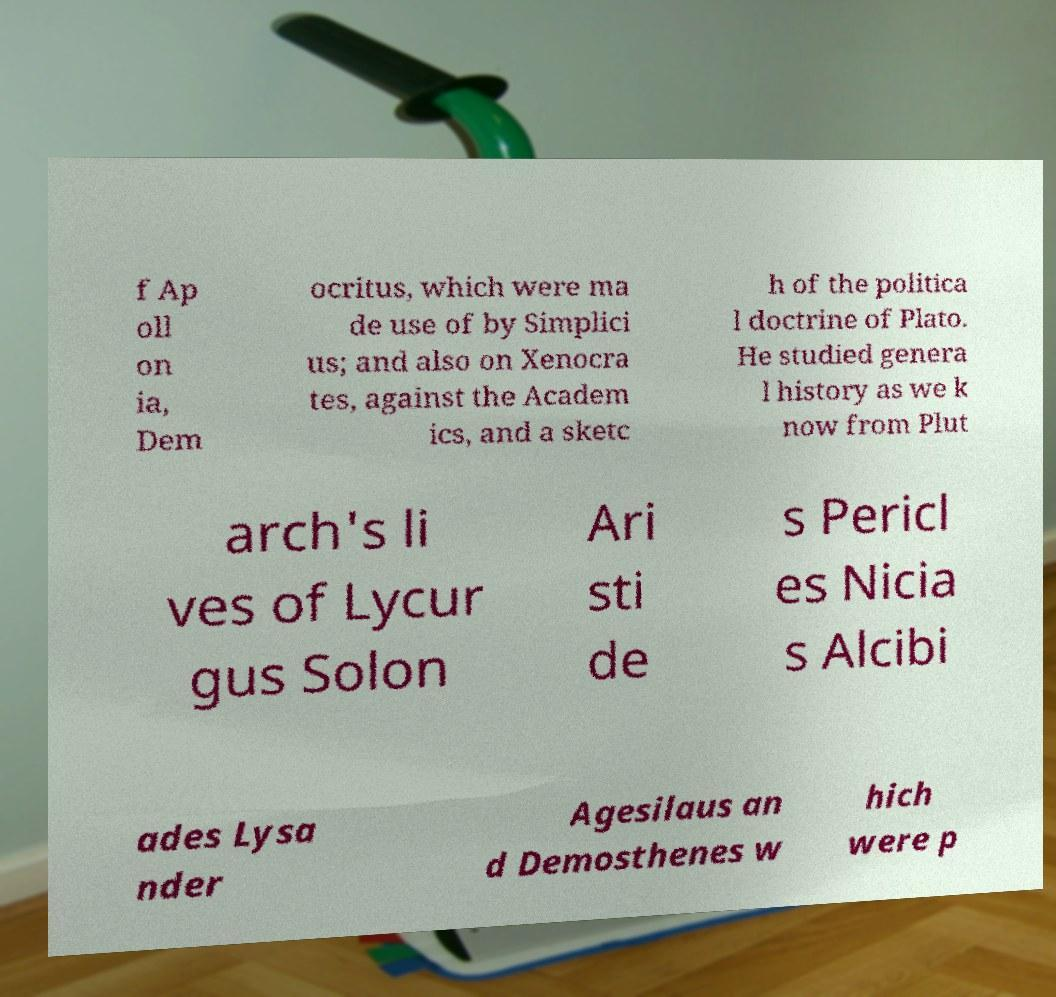Please read and relay the text visible in this image. What does it say? f Ap oll on ia, Dem ocritus, which were ma de use of by Simplici us; and also on Xenocra tes, against the Academ ics, and a sketc h of the politica l doctrine of Plato. He studied genera l history as we k now from Plut arch's li ves of Lycur gus Solon Ari sti de s Pericl es Nicia s Alcibi ades Lysa nder Agesilaus an d Demosthenes w hich were p 